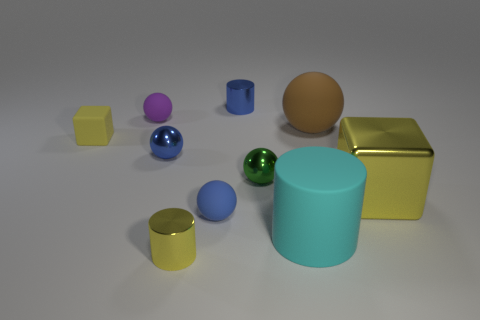Subtract all brown balls. How many balls are left? 4 Subtract all brown balls. How many balls are left? 4 Subtract all red spheres. Subtract all green cylinders. How many spheres are left? 5 Subtract all cylinders. How many objects are left? 7 Add 3 large cyan rubber cylinders. How many large cyan rubber cylinders are left? 4 Add 8 yellow rubber cubes. How many yellow rubber cubes exist? 9 Subtract 1 yellow cylinders. How many objects are left? 9 Subtract all small rubber spheres. Subtract all big matte cylinders. How many objects are left? 7 